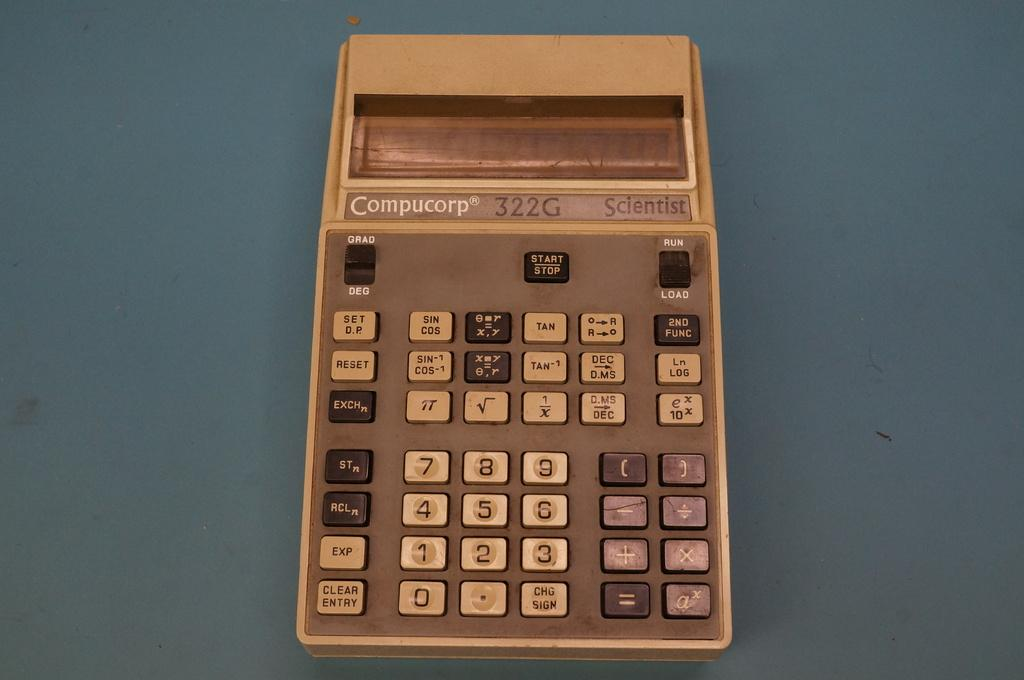<image>
Create a compact narrative representing the image presented. an old compucorp calculator that is beige and is the scientist type 